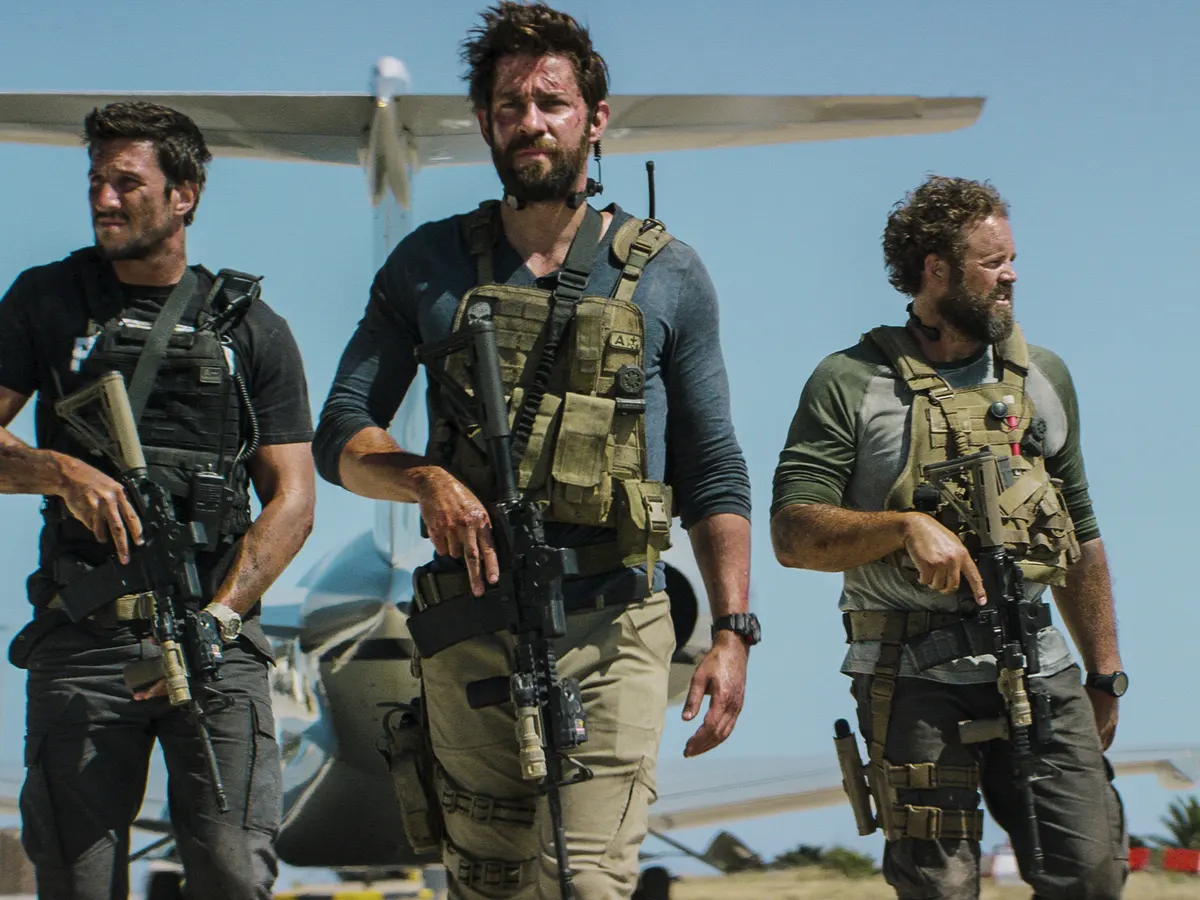How do the background elements enhance the storytelling of this scene? The background, featuring an airstrip and a small airplane under a clear blue sky, plays a crucial part in enhancing the narrative of the image. It sets the scene in a remote or strategically significant location, adding a layer of urgency and mission-critical atmosphere. The openness of the space also emphasizes the isolation of the team, highlighting their teamwork and the gravity of their task. 